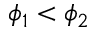Convert formula to latex. <formula><loc_0><loc_0><loc_500><loc_500>\phi _ { 1 } < \phi _ { 2 }</formula> 